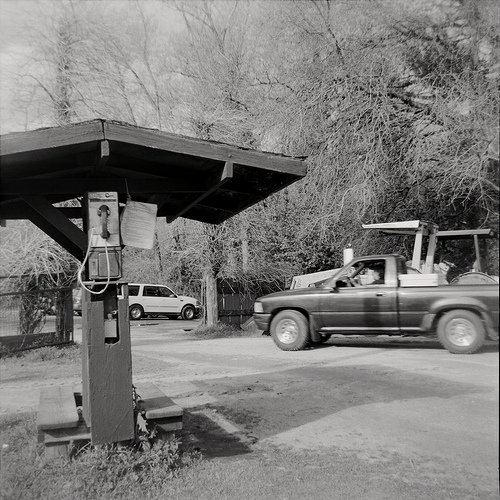Please provide a short description for this region: [0.15, 0.38, 0.24, 0.59]. The area [0.15, 0.38, 0.24, 0.59] shows a telephone situated next to the benches under the wooden structure. 